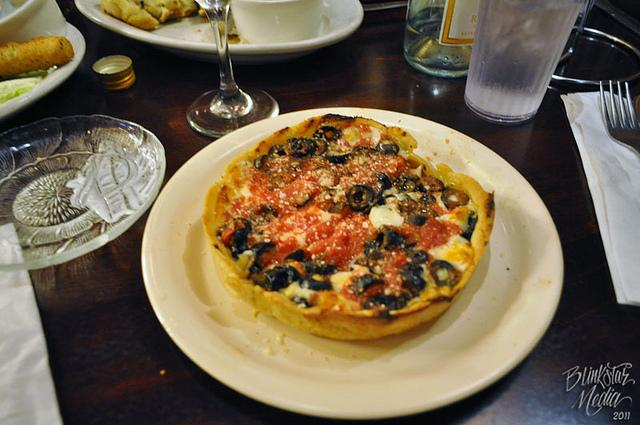What style of pizza is on the plate? Please explain your reasoning. deep dish. Pizza that has a very thick, deep crust is called deep dish. 